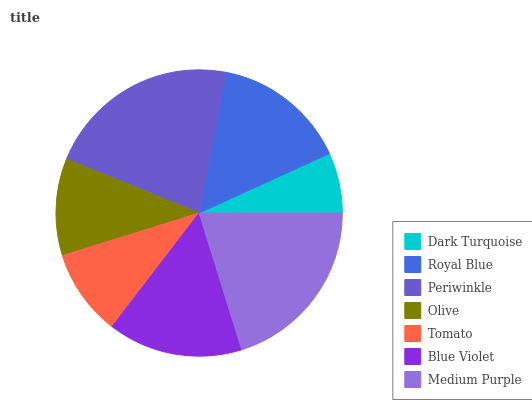Is Dark Turquoise the minimum?
Answer yes or no. Yes. Is Periwinkle the maximum?
Answer yes or no. Yes. Is Royal Blue the minimum?
Answer yes or no. No. Is Royal Blue the maximum?
Answer yes or no. No. Is Royal Blue greater than Dark Turquoise?
Answer yes or no. Yes. Is Dark Turquoise less than Royal Blue?
Answer yes or no. Yes. Is Dark Turquoise greater than Royal Blue?
Answer yes or no. No. Is Royal Blue less than Dark Turquoise?
Answer yes or no. No. Is Royal Blue the high median?
Answer yes or no. Yes. Is Royal Blue the low median?
Answer yes or no. Yes. Is Olive the high median?
Answer yes or no. No. Is Blue Violet the low median?
Answer yes or no. No. 